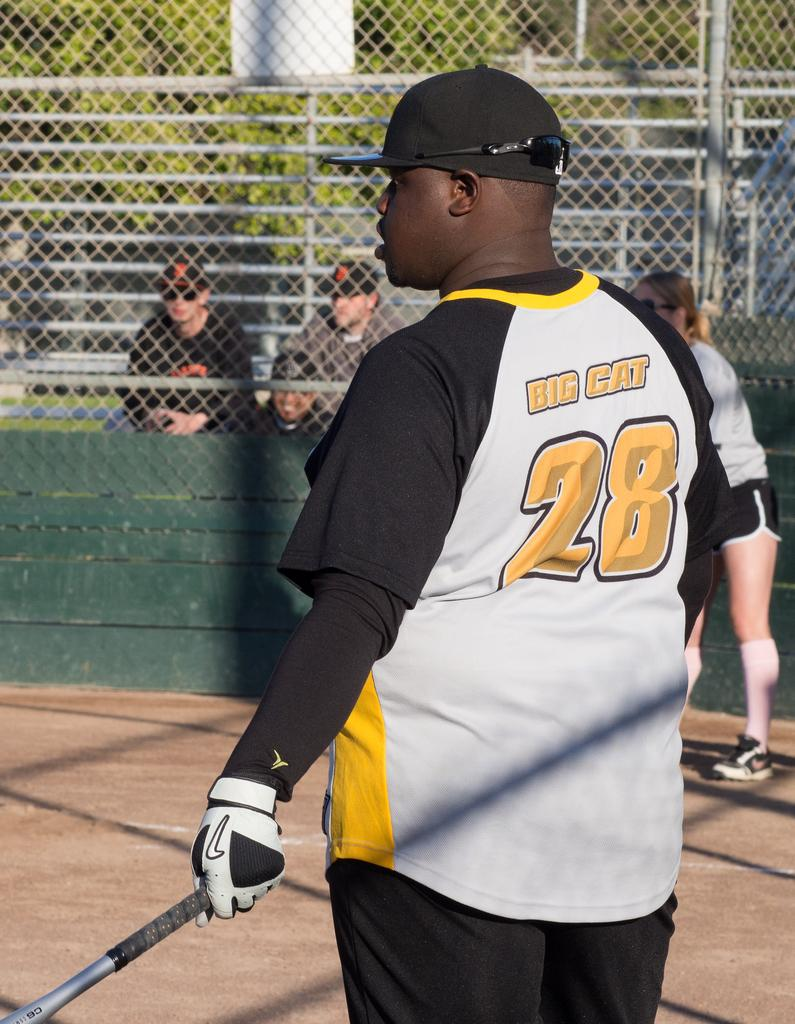<image>
Summarize the visual content of the image. A man with a baseball bat and "Big cat" written on his back 